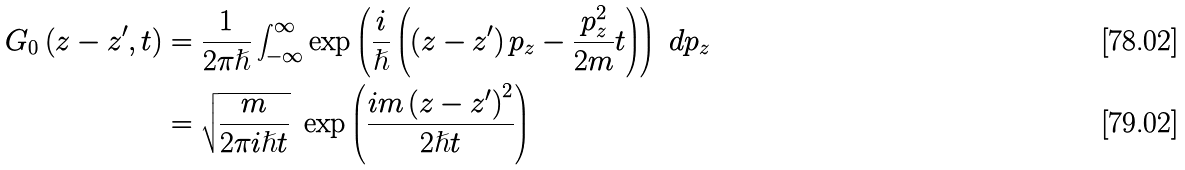Convert formula to latex. <formula><loc_0><loc_0><loc_500><loc_500>G _ { 0 } \left ( z - z ^ { \prime } , t \right ) & = \frac { 1 } { 2 \pi \hslash } \int _ { - \infty } ^ { \infty } \exp \left ( \frac { i } { \hslash } \left ( \left ( z - z ^ { \prime } \right ) p _ { z } - \frac { p _ { z } ^ { 2 } } { 2 m } t \right ) \right ) \ d p _ { z } \\ & = \sqrt { \frac { m } { 2 \pi i \hslash t } } \ \exp \left ( \frac { i m \left ( z - z ^ { \prime } \right ) ^ { 2 } } { 2 \hslash t } \right )</formula> 